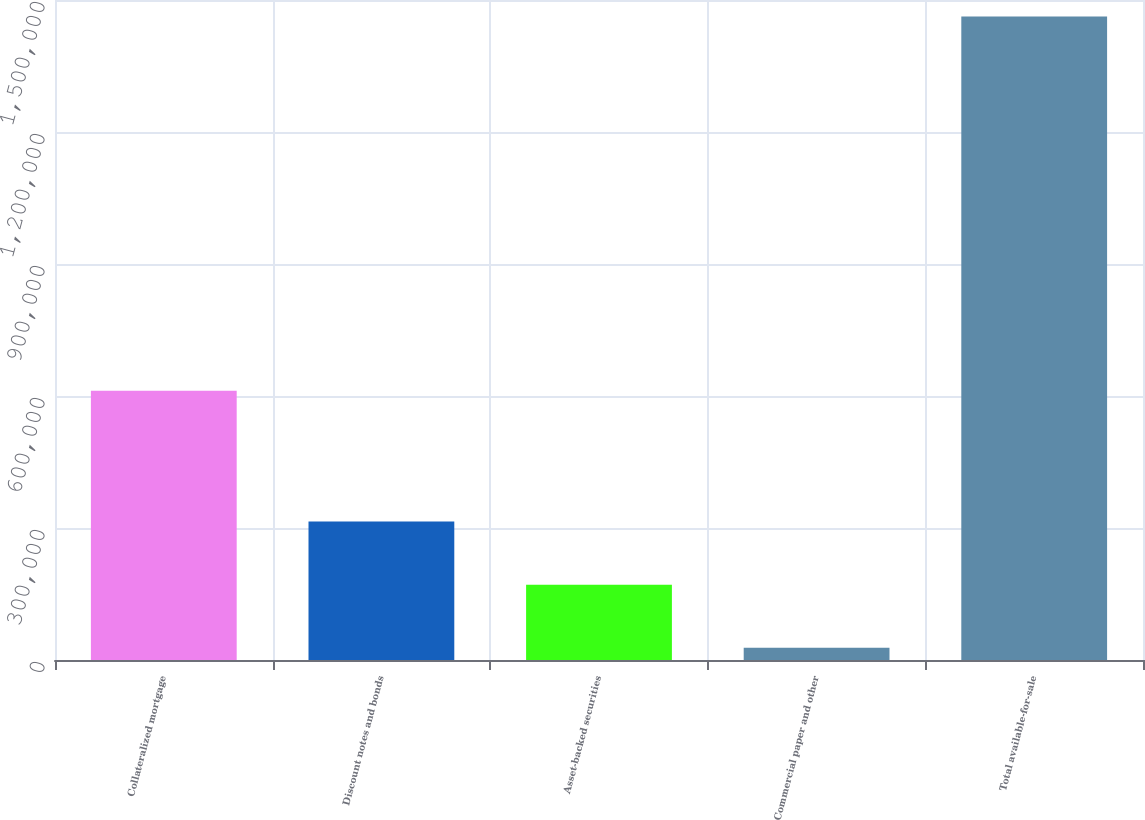<chart> <loc_0><loc_0><loc_500><loc_500><bar_chart><fcel>Collateralized mortgage<fcel>Discount notes and bonds<fcel>Asset-backed securities<fcel>Commercial paper and other<fcel>Total available-for-sale<nl><fcel>612210<fcel>314678<fcel>171228<fcel>27778<fcel>1.46228e+06<nl></chart> 